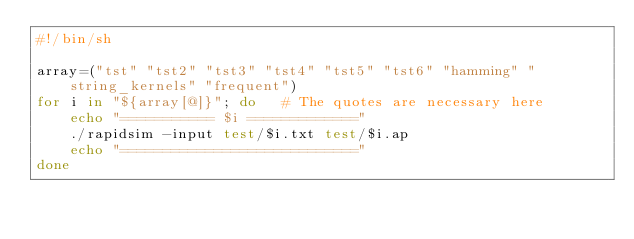<code> <loc_0><loc_0><loc_500><loc_500><_Bash_>#!/bin/sh

array=("tst" "tst2" "tst3" "tst4" "tst5" "tst6" "hamming" "string_kernels" "frequent")
for i in "${array[@]}"; do   # The quotes are necessary here
    echo "=========== $i ============="
    ./rapidsim -input test/$i.txt test/$i.ap
    echo "============================"
done
</code> 